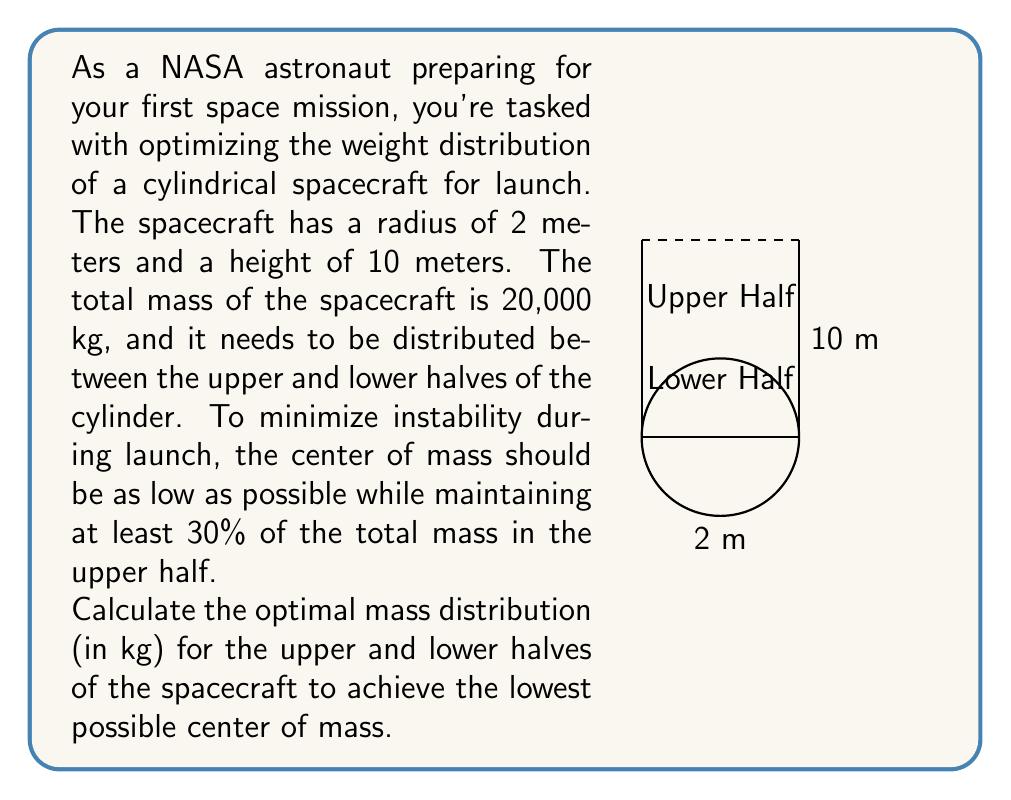Show me your answer to this math problem. Let's approach this step-by-step:

1) Let $x$ be the mass in the upper half of the spacecraft. Then, the mass in the lower half is $(20000 - x)$ kg.

2) The constraint of at least 30% mass in the upper half can be expressed as:
   $x \geq 0.3 \times 20000 = 6000$ kg

3) To minimize instability, we want to put as much mass as possible in the lower half while satisfying this constraint. Therefore, the optimal solution will have exactly 30% of the mass in the upper half:
   $x = 6000$ kg (upper half)
   $20000 - x = 14000$ kg (lower half)

4) Now, let's calculate the center of mass. We can treat each half as a point mass located at its centroid:
   - Upper half centroid: 7.5 meters from the base
   - Lower half centroid: 2.5 meters from the base

5) The center of mass formula is:
   $$y_{cm} = \frac{\sum m_i y_i}{\sum m_i}$$

   Where $m_i$ is the mass of each part and $y_i$ is the distance of its centroid from the base.

6) Plugging in our values:
   $$y_{cm} = \frac{6000 \times 7.5 + 14000 \times 2.5}{20000}$$

7) Simplifying:
   $$y_{cm} = \frac{45000 + 35000}{20000} = \frac{80000}{20000} = 4 \text{ meters}$$

Thus, the optimal distribution places the center of mass 4 meters from the base of the spacecraft.
Answer: Upper half: 6000 kg, Lower half: 14000 kg 